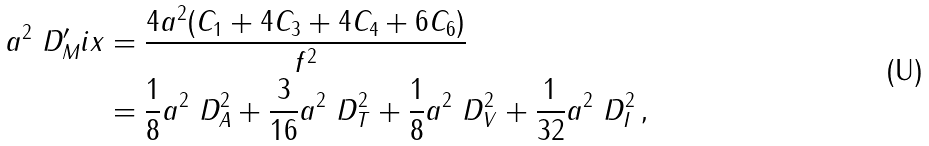Convert formula to latex. <formula><loc_0><loc_0><loc_500><loc_500>a ^ { 2 } \ D ^ { \prime } _ { M } i x & = \frac { 4 a ^ { 2 } ( C _ { 1 } + 4 C _ { 3 } + 4 C _ { 4 } + 6 C _ { 6 } ) } { f ^ { 2 } } \\ & = \frac { 1 } { 8 } a ^ { 2 } \ D _ { A } ^ { 2 } + \frac { 3 } { 1 6 } a ^ { 2 } \ D _ { T } ^ { 2 } + \frac { 1 } { 8 } a ^ { 2 } \ D _ { V } ^ { 2 } + \frac { 1 } { 3 2 } a ^ { 2 } \ D _ { I } ^ { 2 } \, ,</formula> 